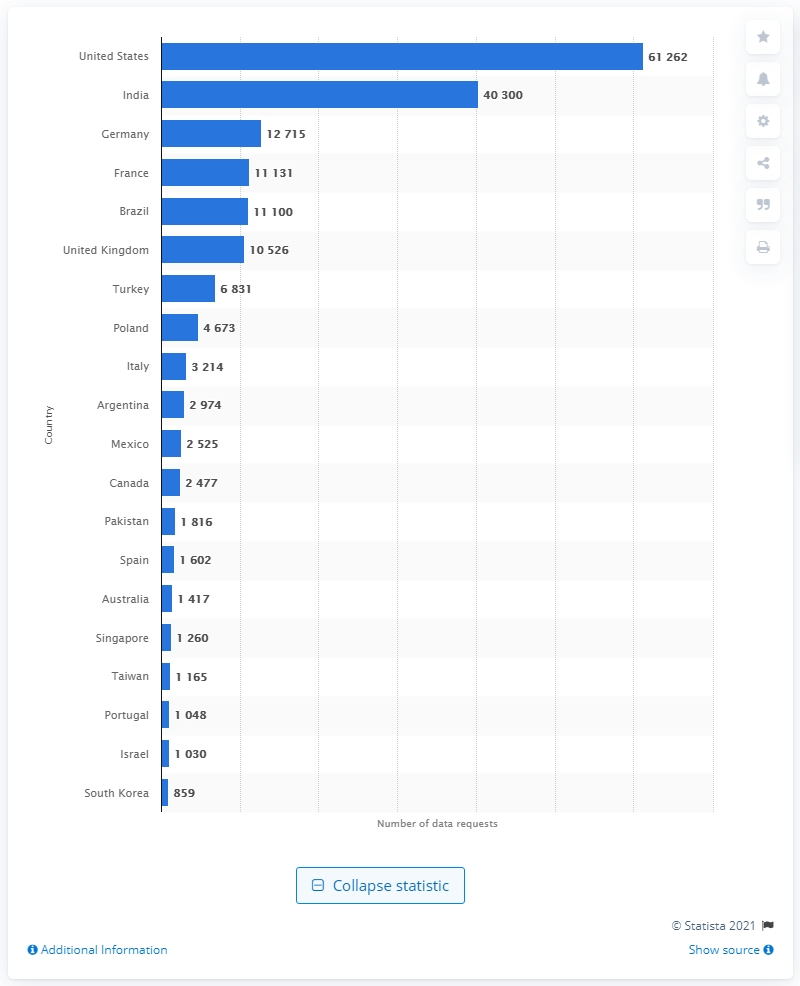Outline some significant characteristics in this image. India was ranked second, with 40,300 user data requests. 